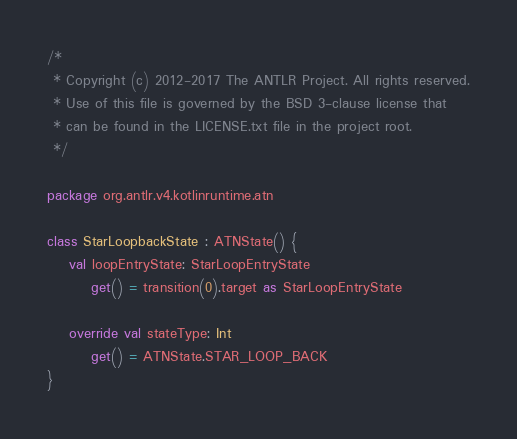Convert code to text. <code><loc_0><loc_0><loc_500><loc_500><_Kotlin_>/*
 * Copyright (c) 2012-2017 The ANTLR Project. All rights reserved.
 * Use of this file is governed by the BSD 3-clause license that
 * can be found in the LICENSE.txt file in the project root.
 */

package org.antlr.v4.kotlinruntime.atn

class StarLoopbackState : ATNState() {
    val loopEntryState: StarLoopEntryState
        get() = transition(0).target as StarLoopEntryState

    override val stateType: Int
        get() = ATNState.STAR_LOOP_BACK
}
</code> 